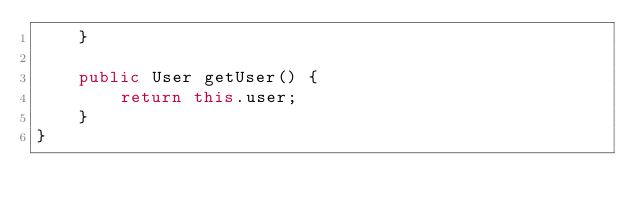Convert code to text. <code><loc_0><loc_0><loc_500><loc_500><_Java_>    }

    public User getUser() {
        return this.user;
    }
}
</code> 